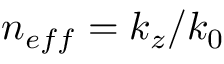<formula> <loc_0><loc_0><loc_500><loc_500>n _ { e f f } = k _ { z } / k _ { 0 }</formula> 